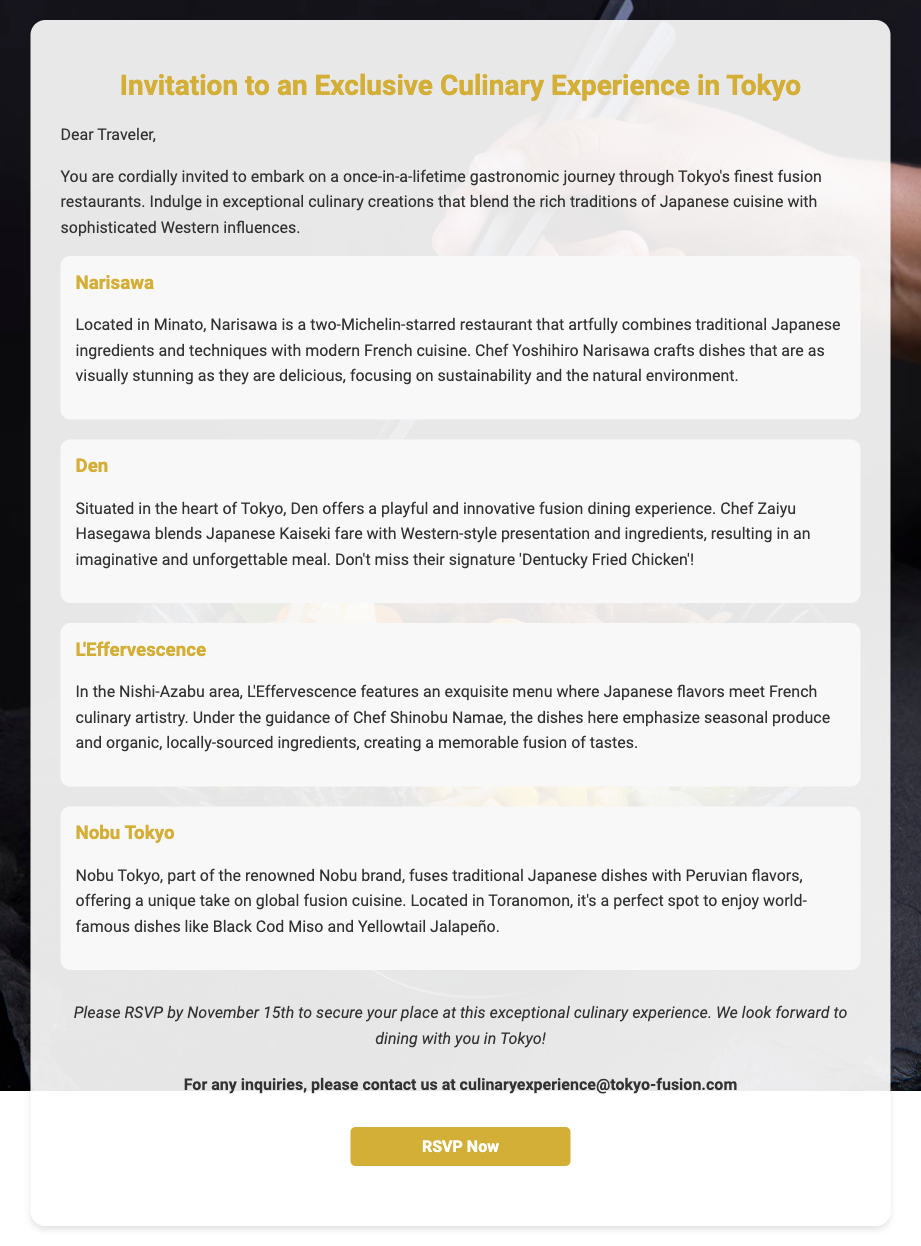What is the date to RSVP by? The RSVP deadline is mentioned clearly in the document, which states to RSVP by November 15th.
Answer: November 15th How many Michelin stars does Narisawa have? The document states that Narisawa is a two-Michelin-starred restaurant.
Answer: two What dish is Den famous for? The document highlights Den's signature dish called 'Dentucky Fried Chicken.'
Answer: Dentucky Fried Chicken Which area is L'Effervescence located in? The location of L'Effervescence is specified in the document as being in Nishi-Azabu.
Answer: Nishi-Azabu What type of cuisine does Nobu Tokyo fuse? The document describes Nobu Tokyo as fusing traditional Japanese dishes with Peruvian flavors.
Answer: Japanese and Peruvian What should you do to secure your place? To secure a place at the culinary experience, you need to RSVP.
Answer: RSVP Who can you contact for inquiries about the event? The document provides a contact email for inquiries, which can be found at the end.
Answer: culinaryexperience@tokyo-fusion.com What is the main theme of the invitation? The main theme focuses on experiencing the blend of traditional Japanese cuisine with Western influences.
Answer: fusion cuisine 